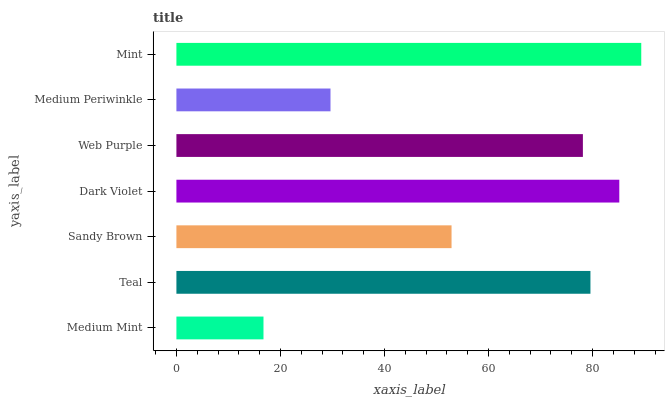Is Medium Mint the minimum?
Answer yes or no. Yes. Is Mint the maximum?
Answer yes or no. Yes. Is Teal the minimum?
Answer yes or no. No. Is Teal the maximum?
Answer yes or no. No. Is Teal greater than Medium Mint?
Answer yes or no. Yes. Is Medium Mint less than Teal?
Answer yes or no. Yes. Is Medium Mint greater than Teal?
Answer yes or no. No. Is Teal less than Medium Mint?
Answer yes or no. No. Is Web Purple the high median?
Answer yes or no. Yes. Is Web Purple the low median?
Answer yes or no. Yes. Is Medium Mint the high median?
Answer yes or no. No. Is Sandy Brown the low median?
Answer yes or no. No. 